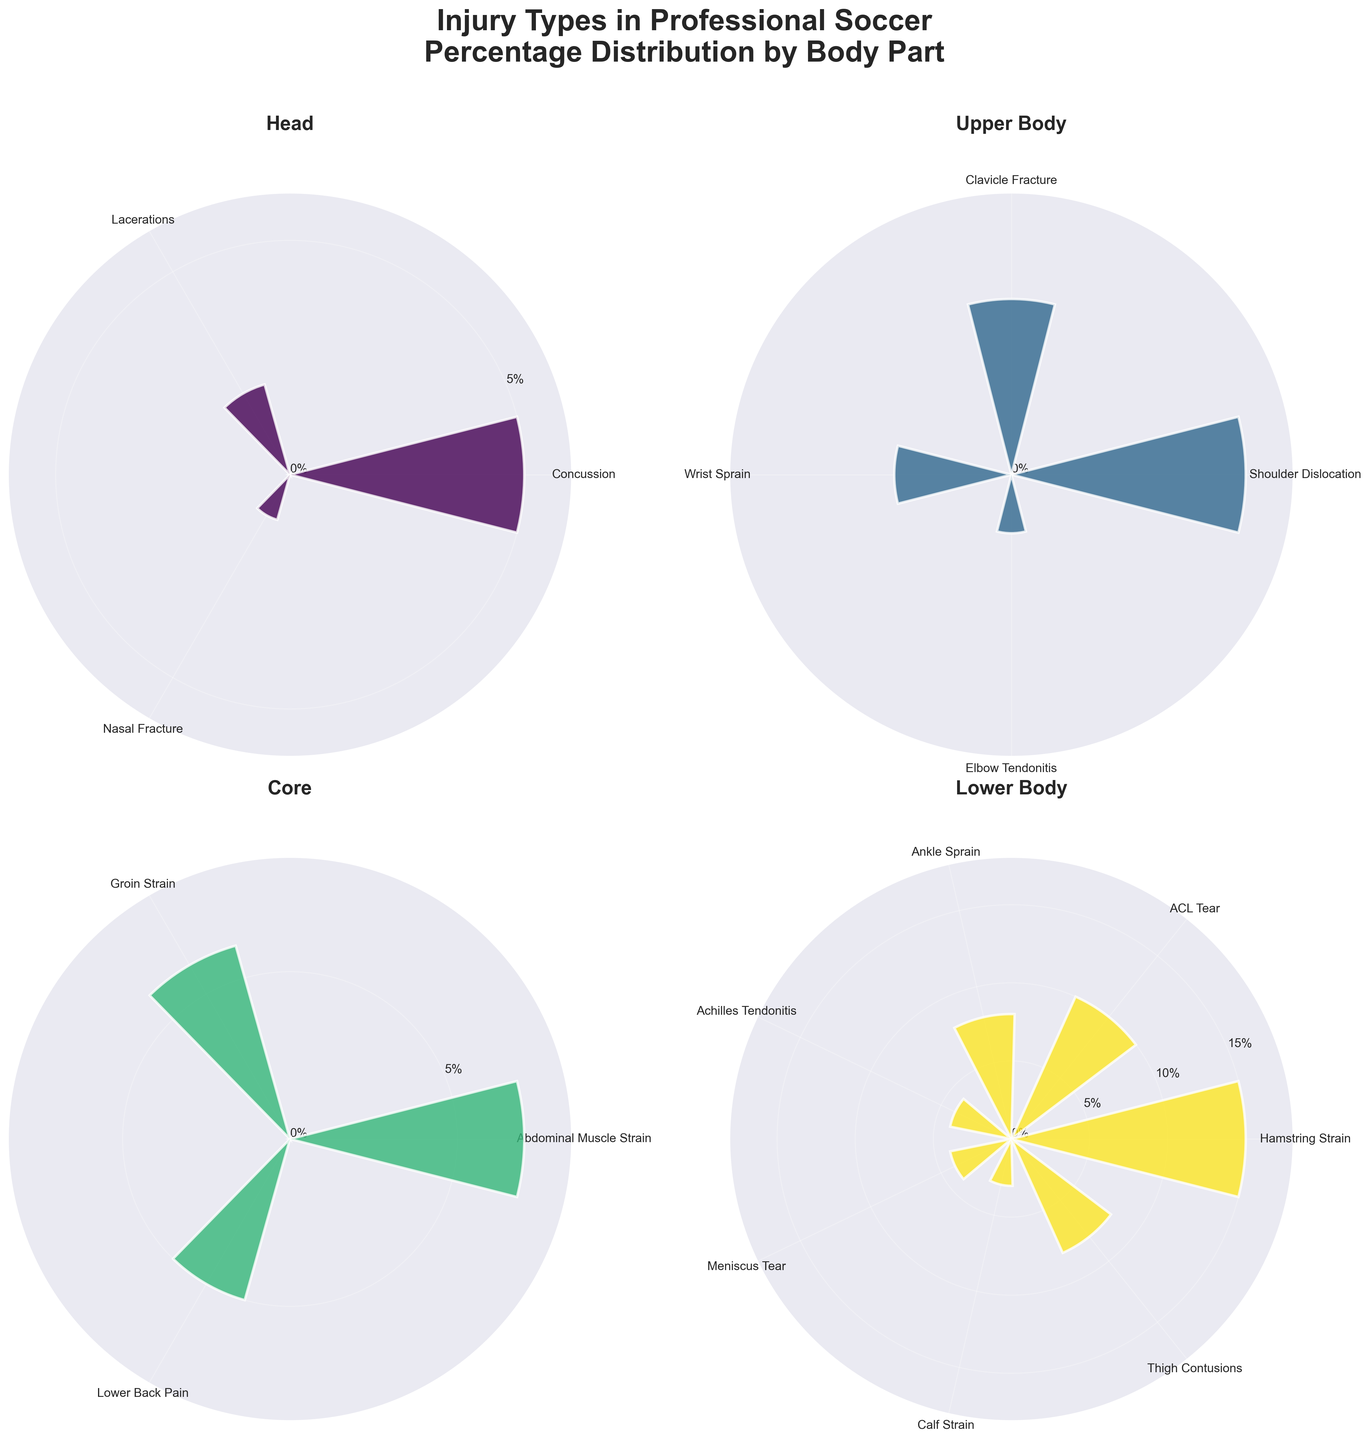What is the title of the figure? The title is displayed at the top of the figure in a larger, bold font. From the description given, the title is "Injury Types in Professional Soccer\nPercentage Distribution by Body Part".
Answer: Injury Types in Professional Soccer\nPercentage Distribution by Body Part Which body part section has the highest injury percentage? The Lower Body section includes Hamstring Strain at 15%, which is the highest percentage in the figure.
Answer: Lower Body How many injury types are represented in the Head section? The Head section lists three injury types: Concussion, Lacerations, and Nasal Fracture.
Answer: 3 What is the combined percentage of injuries for the Core section? The percentages in the Core section are 7% for Abdominal Muscle Strain, 6% for Groin Strain, and 5% for Lower Back Pain. Adding these together equals 7 + 6 + 5 = 18%.
Answer: 18% Does Upper Body or Lower Body have a higher total percentage of injuries? The Upper Body section includes 4% for Shoulder Dislocation, 3% for Clavicle Fracture, 2% for Wrist Sprain, and 1% for Elbow Tendonitis, totaling 4 + 3 + 2 + 1 = 10%. The Lower Body section totals 15% for Hamstring Strain, 10% for ACL Tear, 8% for Ankle Sprain, 4% for Achilles Tendonitis, 4% for Meniscus Tear, 3% for Calf Strain, and 8% for Thigh Contusions, totaling 15 + 10 + 8 + 4 + 4 + 3 + 8 = 52%. Therefore, Lower Body has a higher total percentage.
Answer: Lower Body Which injury type in the Lower Body section has the lowest percentage? The injury type in the Lower Body section with the lowest percentage is Calf Strain at 3%.
Answer: Calf Strain What are the percentages of Concussion compared to ACL Tear? The percentage for Concussion in the Head section is 5%, and the percentage for ACL Tear in the Lower Body section is 10%. ACL Tear is double that of Concussion.
Answer: 5% vs. 10% What is the average percentage of the injury types in the Upper Body section? The injury types in the Upper Body section have percentages 4%, 3%, 2%, and 1%. The average percentage is calculated by (4 + 3 + 2 + 1)/4 = 2.5%.
Answer: 2.5% Which section has more types of injuries, Core or Lower Body? The Core section has three injury types: Abdominal Muscle Strain, Groin Strain, and Lower Back Pain. The Lower Body section has seven injury types: Hamstring Strain, ACL Tear, Ankle Sprain, Achilles Tendonitis, Meniscus Tear, Calf Strain, and Thigh Contusions. Therefore, Lower Body has more types of injuries.
Answer: Lower Body What are the four sections of body parts represented in the plot? The titles of the plot sections indicate the body parts: Head, Upper Body, Core, and Lower Body.
Answer: Head, Upper Body, Core, Lower Body 